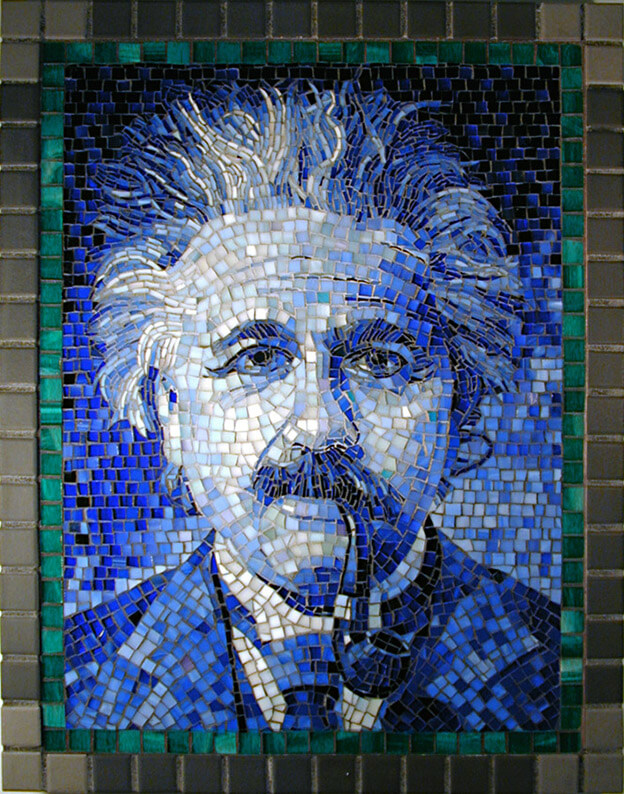Considering the level of detail and the chosen colors for the mosaic, what might have been the artist's intention in choosing this particular color palette for the portrait, and how does it contribute to the overall perception of the figure depicted? The selection of a predominantly blue color palette in the mosaic likely serves multiple symbolic purposes. Blue, associated with tranquility, intelligence, and depth, aligns well with the figure’s perceived characteristics – often seen as an emblem of profound intellectualism. The artist might have chosen darker blues to project an aura of mystery and the infinite nature of thought, thereby providing a visual depth that enhances the figure's perceived mental expansiveness. The gradual lightening of the blues transitioning to greens further layers the image with notions of vitality and a connection to life, implying that the ideas and thoughts of the figure are not only theoretically significant but also practically impactful. This artistic strategy using a gradient from celestial to terrestrial hues could be intended to suggest that the figure’s insights bridge the gap between high theory and earthly existence. Overall, this thoughtful use of a color gradient reinforces the figure's stature as a thoughtful, grounded philosopher, whose ideas continue to influence both abstract theory and practical application. 